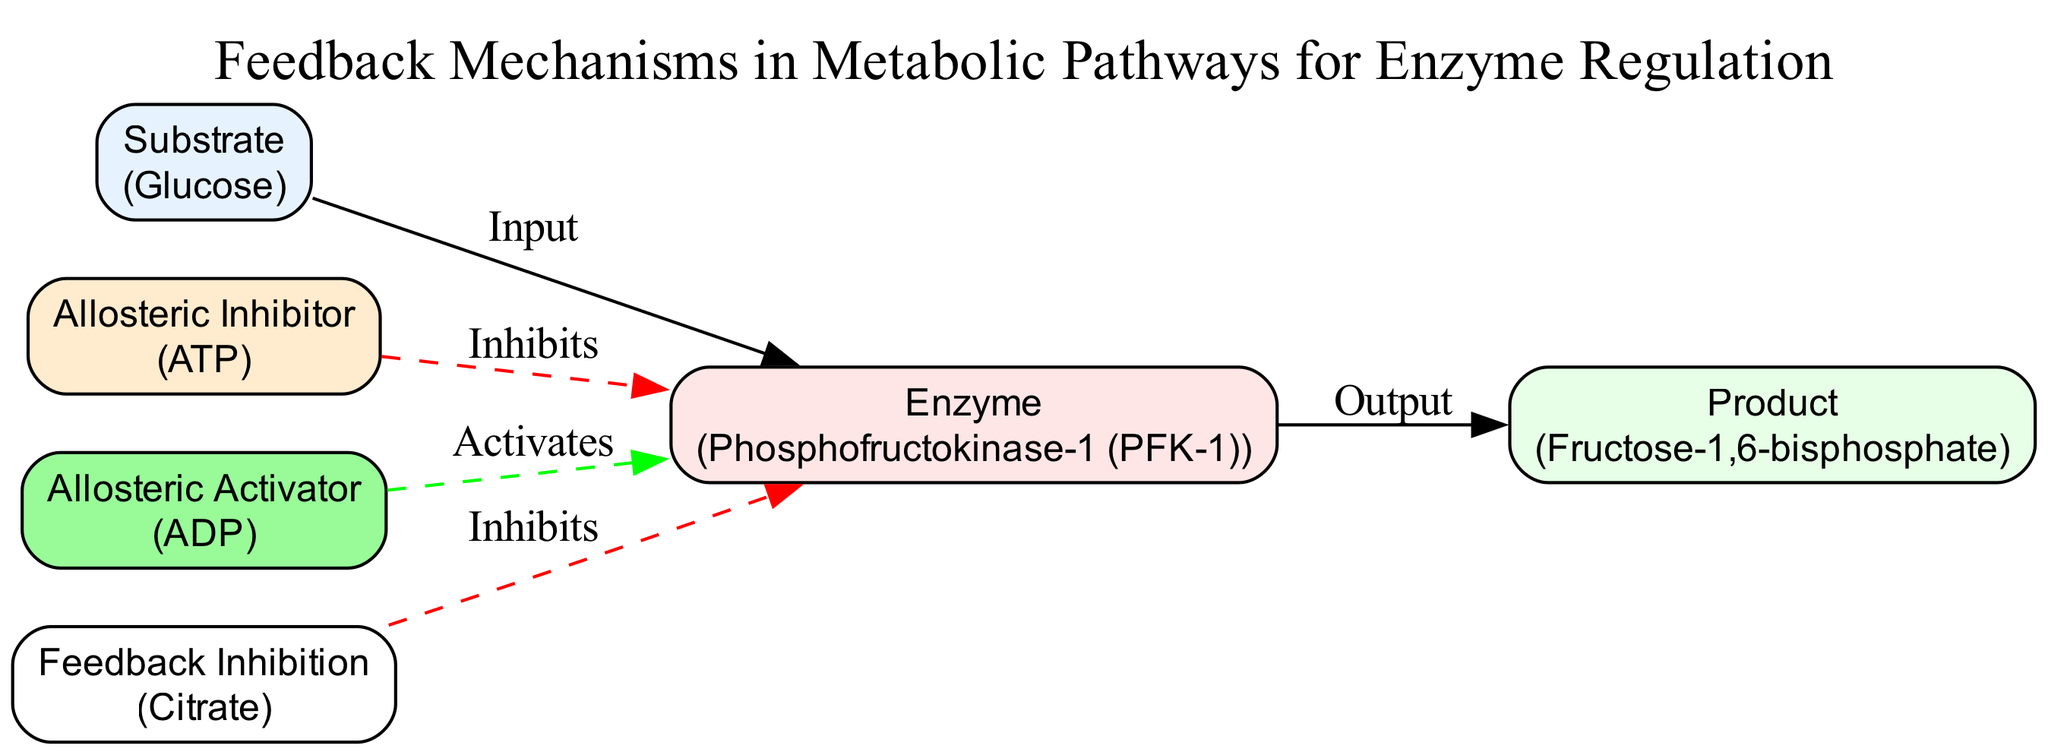What is the initial substrate in this pathway? The diagram specifies "Glucose" as the initial substrate under the "Substrate" node.
Answer: Glucose Which enzyme is regulated in this metabolic pathway? The diagram identifies "Phosphofructokinase-1 (PFK-1)" as the key regulatory enzyme, indicated under the "Enzyme" node.
Answer: Phosphofructokinase-1 (PFK-1) What is the product of the reaction catalyzed by the enzyme? According to the diagram, the output from the enzyme is "Fructose-1,6-bisphosphate," detailed under the "Product" node.
Answer: Fructose-1,6-bisphosphate How many allosteric regulators affect the enzyme? The diagram shows two regulators affecting the enzyme: "ATP" (an allosteric inhibitor) and "ADP" (an allosteric activator). Thus, the count is two.
Answer: 2 What can be inferred if ATP levels are high? High levels of ATP are indicated to inhibit PFK-1, suggesting there is sufficient energy and signaling is needed to slow down glycolysis.
Answer: Inhibits How does citrate feedback to the enzyme? The diagram illustrates that high levels of citrate provide feedback inhibition to PFK-1, implying that an abundance of citrate indicates a backlog in the citric acid cycle, reinforcing the slowing of the glycolytic pathway.
Answer: Inhibits What is the role of ADP in this pathway? ADP acts as an allosteric activator, indicating low energy availability, and thus increasing PFK-1 activity to promote glycolysis when energy levels are inadequate.
Answer: Activates What type of diagram is used to represent these metabolic processes? This diagram is a "Sequence diagram," which visually represents the sequence of metabolic steps and regulatory interactions within the pathway.
Answer: Sequence diagram Which node indicates the presence of an allosteric inhibitor? The "Allosteric Inhibitor" node in the diagram indicates the presence of ATP as the regulating substance that inhibits the enzyme activity.
Answer: ATP What edge connects the substrate to the enzyme? The edge connecting the "Substrate" to the "Enzyme" is labeled as "Input," indicating the flow of the substrate into the enzyme for the reaction.
Answer: Input 